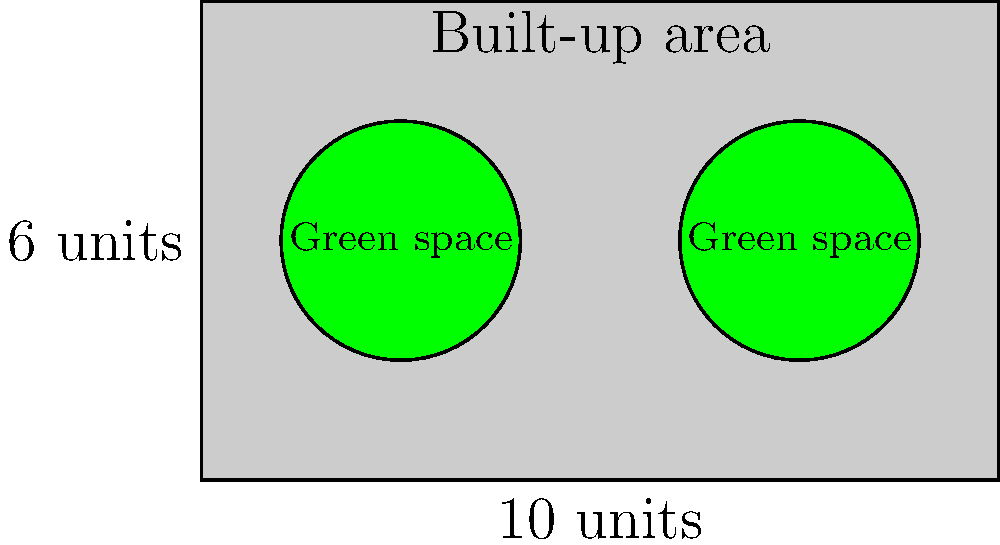In an urban planning project, you're analyzing a rectangular plot of land measuring 10 units by 6 units. The plot contains two circular green spaces, each with a radius of 1.5 units. What is the ratio of the total green space area to the total built-up area? Express your answer as a simplified fraction. Let's approach this step-by-step:

1) Calculate the total area of the plot:
   $A_{total} = 10 \times 6 = 60$ square units

2) Calculate the area of one green space (circle):
   $A_{circle} = \pi r^2 = \pi \times 1.5^2 = 2.25\pi$ square units

3) Calculate the total green space area (two circles):
   $A_{green} = 2 \times 2.25\pi = 4.5\pi$ square units

4) Calculate the built-up area:
   $A_{built} = A_{total} - A_{green} = 60 - 4.5\pi$ square units

5) Calculate the ratio of green space to built-up area:
   $\text{Ratio} = \frac{A_{green}}{A_{built}} = \frac{4.5\pi}{60 - 4.5\pi}$

6) Simplify the ratio:
   $\frac{4.5\pi}{60 - 4.5\pi} = \frac{9\pi}{120 - 9\pi}$

This fraction cannot be simplified further without approximating $\pi$.
Answer: $\frac{9\pi}{120 - 9\pi}$ 